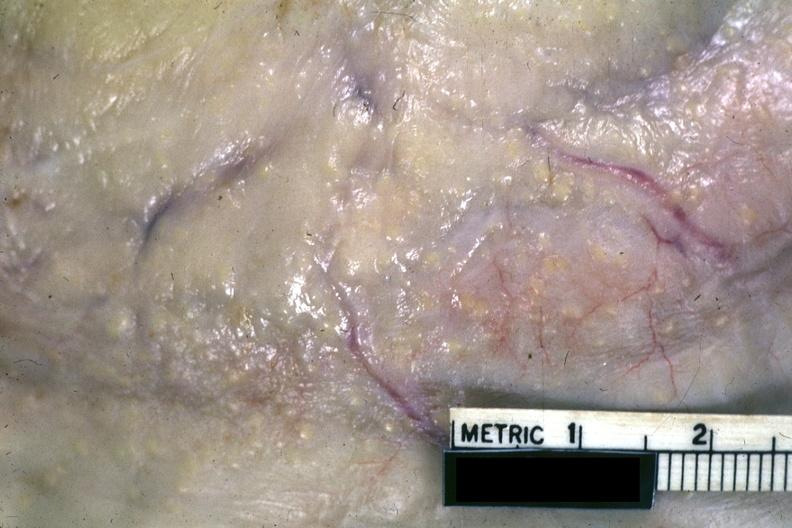what is present?
Answer the question using a single word or phrase. Peritoneum 